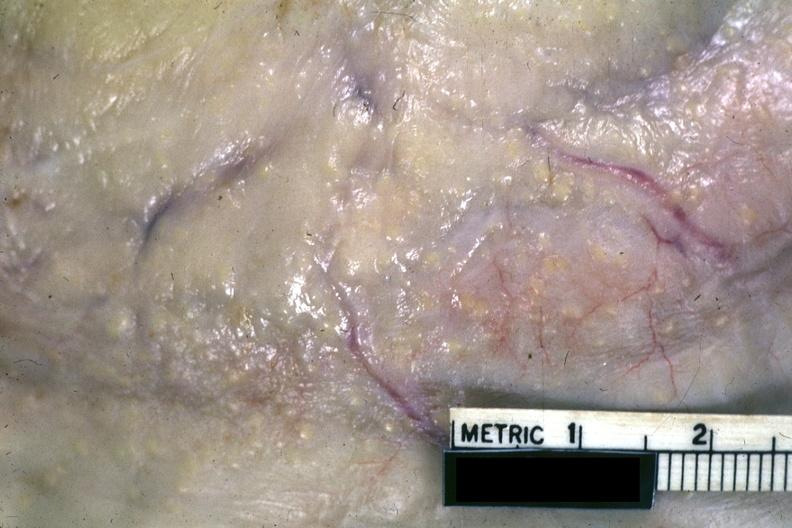what is present?
Answer the question using a single word or phrase. Peritoneum 